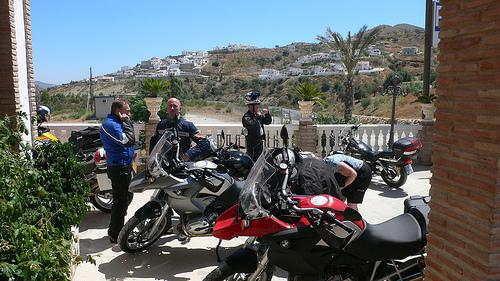What does the environment suggest about the usual activities that might take place here? The environment, with its clear skies and mountainous backdrop, suggests that this area might be popular for motorbike touring. The relaxed posture of the people and the rural setting indicate it could be a common stop or meeting point for riders exploring the region. 